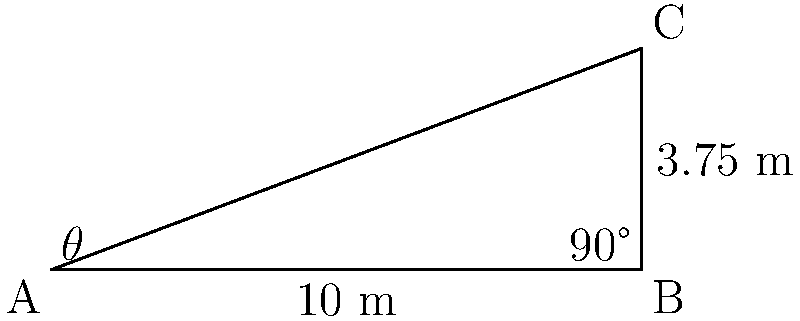During a Liverpool FC match, Mohamed Salah is preparing to take a corner kick. The corner flag is at point A, the near goal post is at point B, and the far goal post is at point C. If the distance between the goal posts (BC) is 3.75 meters, and the distance from the corner flag to the near goal post (AB) is 10 meters, what is the angle $\theta$ of the corner kick (angle CAB) that Salah needs to aim for to reach the far post? Let's solve this step-by-step using trigonometry:

1) First, we need to recognize that we have a right-angled triangle ABC, where the right angle is at B.

2) We know two sides of this triangle:
   AB = 10 meters (given)
   BC = 3.75 meters (given)

3) To find angle $\theta$, we can use the arctangent function. We need to find the ratio of the opposite side (BC) to the adjacent side (AB).

4) The tangent of $\theta$ is:
   $$\tan(\theta) = \frac{opposite}{adjacent} = \frac{BC}{AB} = \frac{3.75}{10}$$

5) To find $\theta$, we take the arctangent (or inverse tangent) of this ratio:
   $$\theta = \arctan(\frac{3.75}{10})$$

6) Using a calculator or computer:
   $$\theta \approx 20.556°$$

7) Rounding to the nearest degree:
   $$\theta \approx 21°$$

Therefore, Salah should aim for an angle of approximately 21° from the goal line to reach the far post with his corner kick.
Answer: $21°$ 